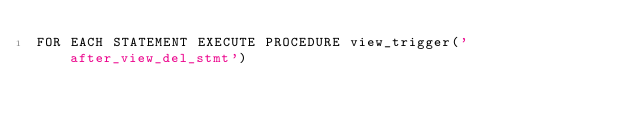<code> <loc_0><loc_0><loc_500><loc_500><_SQL_>FOR EACH STATEMENT EXECUTE PROCEDURE view_trigger('after_view_del_stmt')
</code> 